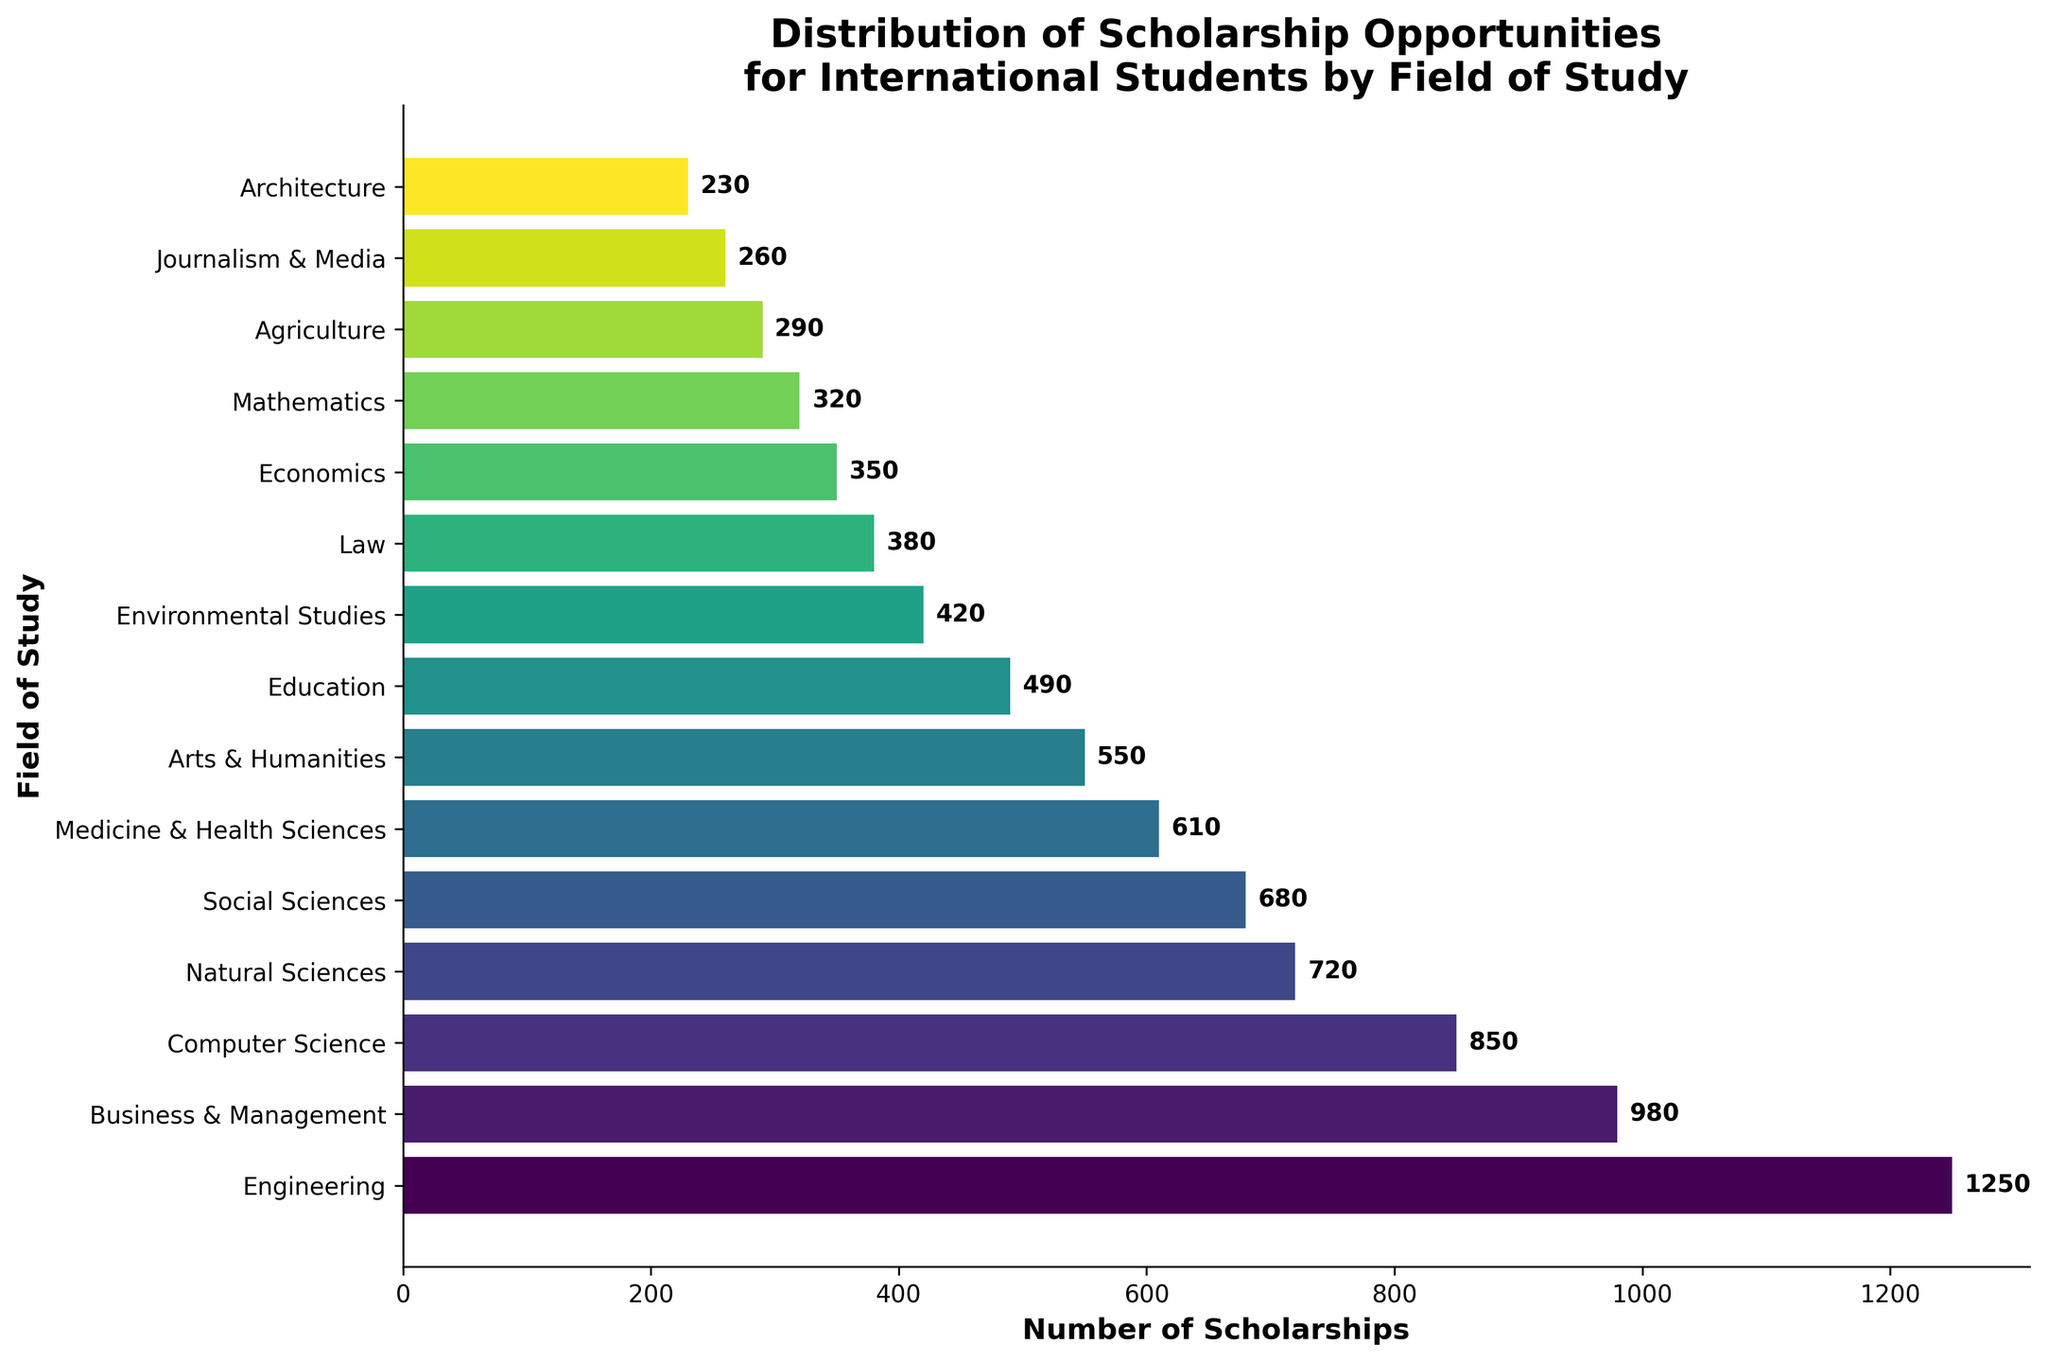What is the field of study with the most scholarship opportunities? The top bar representing the field of study with the most scholarships is Engineering with 1250 scholarships.
Answer: Engineering How many more scholarships are there for Business & Management compared to Law? Business & Management has 980 scholarships, while Law has 380. Subtracting the two gives the difference: 980 - 380 = 600.
Answer: 600 Which fields of study have fewer than 500 scholarship opportunities? Fields of study with fewer than 500 scholarships include Education (490), Environmental Studies (420), Law (380), Economics (350), Mathematics (320), Agriculture (290), Journalism & Media (260), and Architecture (230).
Answer: Education, Environmental Studies, Law, Economics, Mathematics, Agriculture, Journalism & Media, Architecture What is the combined number of scholarships for Natural Sciences, Social Sciences, and Arts & Humanities? Adding the number of scholarships for Natural Sciences (720), Social Sciences (680), and Arts & Humanities (550) gives the total: 720 + 680 + 550 = 1950.
Answer: 1950 Which field of study has scholarships closest in number to Medicine & Health Sciences? Medicine & Health Sciences has 610 scholarships. The closest number is Social Sciences with 680 scholarships, which is 610 + 70 = 680.
Answer: Social Sciences Rank the fields with fewer than 350 scholarships from most to least. Fields of study with fewer than 350 scholarships are Economics (350), Mathematics (320), Agriculture (290), Journalism & Media (260), and Architecture (230). Their ranks from most to least are: Economics, Mathematics, Agriculture, Journalism & Media, Architecture.
Answer: Economics, Mathematics, Agriculture, Journalism & Media, Architecture How does the number of scholarships for Computer Science compare to Engineering? Computer Science has 850 scholarships, and Engineering has 1250. The comparison shows that Engineering has more scholarships: 1250 - 850 = 400 more than Computer Science.
Answer: 400 more What's the total number of scholarships for all fields of study? Adding the number of scholarships for all fields: 1250 (Engineering) + 980 (Business & Management) + 850 (Computer Science) + 720 (Natural Sciences) + 680 (Social Sciences) + 610 (Medicine & Health Sciences) + 550 (Arts & Humanities) + 490 (Education) + 420 (Environmental Studies) + 380 (Law) + 350 (Economics) + 320 (Mathematics) + 290 (Agriculture) + 260 (Journalism & Media) + 230 (Architecture) equals 8880.
Answer: 8880 What percentage of the scholarships go to Engineering? Engineering has 1250 scholarships out of a total 8880. The percentage is (1250/8880) * 100 ≈ 14.07%.
Answer: 14.07% 